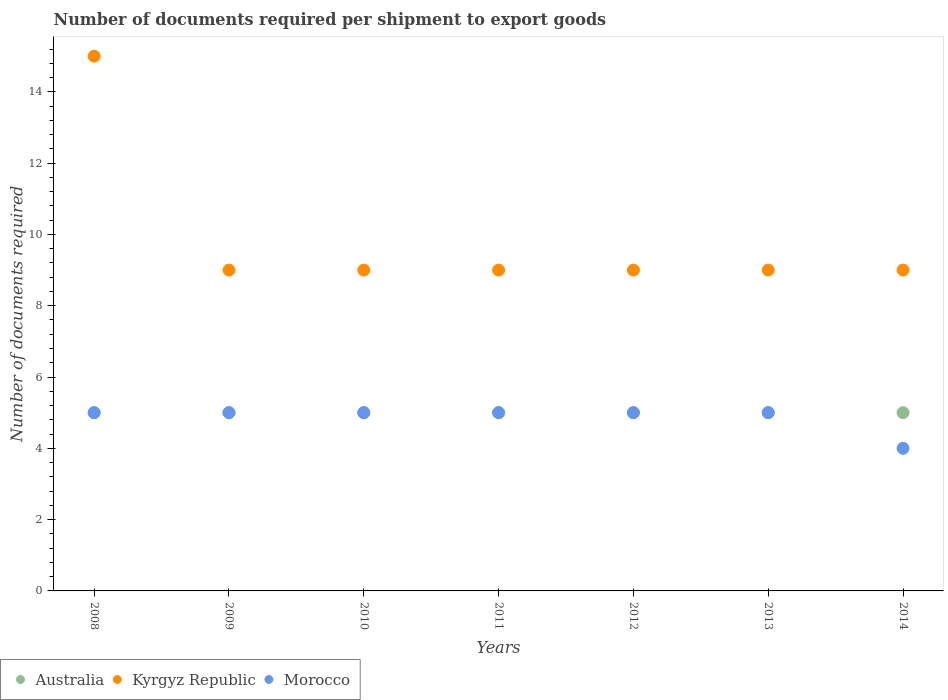Is the number of dotlines equal to the number of legend labels?
Make the answer very short. Yes. What is the number of documents required per shipment to export goods in Morocco in 2009?
Your answer should be very brief. 5. Across all years, what is the maximum number of documents required per shipment to export goods in Morocco?
Offer a terse response. 5. Across all years, what is the minimum number of documents required per shipment to export goods in Morocco?
Offer a very short reply. 4. In which year was the number of documents required per shipment to export goods in Morocco maximum?
Your answer should be very brief. 2008. In which year was the number of documents required per shipment to export goods in Morocco minimum?
Your answer should be very brief. 2014. What is the total number of documents required per shipment to export goods in Kyrgyz Republic in the graph?
Your answer should be very brief. 69. What is the difference between the number of documents required per shipment to export goods in Australia in 2009 and that in 2012?
Make the answer very short. 0. What is the difference between the number of documents required per shipment to export goods in Kyrgyz Republic in 2014 and the number of documents required per shipment to export goods in Australia in 2012?
Provide a short and direct response. 4. What is the average number of documents required per shipment to export goods in Kyrgyz Republic per year?
Make the answer very short. 9.86. In how many years, is the number of documents required per shipment to export goods in Australia greater than 11.2?
Offer a very short reply. 0. What is the ratio of the number of documents required per shipment to export goods in Morocco in 2010 to that in 2011?
Ensure brevity in your answer.  1. What is the difference between the highest and the lowest number of documents required per shipment to export goods in Australia?
Ensure brevity in your answer.  0. Is the sum of the number of documents required per shipment to export goods in Kyrgyz Republic in 2008 and 2011 greater than the maximum number of documents required per shipment to export goods in Morocco across all years?
Ensure brevity in your answer.  Yes. Is it the case that in every year, the sum of the number of documents required per shipment to export goods in Australia and number of documents required per shipment to export goods in Morocco  is greater than the number of documents required per shipment to export goods in Kyrgyz Republic?
Ensure brevity in your answer.  No. Does the number of documents required per shipment to export goods in Morocco monotonically increase over the years?
Ensure brevity in your answer.  No. How many dotlines are there?
Provide a short and direct response. 3. How many years are there in the graph?
Give a very brief answer. 7. What is the difference between two consecutive major ticks on the Y-axis?
Your response must be concise. 2. Are the values on the major ticks of Y-axis written in scientific E-notation?
Provide a short and direct response. No. Does the graph contain any zero values?
Give a very brief answer. No. What is the title of the graph?
Keep it short and to the point. Number of documents required per shipment to export goods. What is the label or title of the Y-axis?
Make the answer very short. Number of documents required. What is the Number of documents required in Australia in 2008?
Keep it short and to the point. 5. What is the Number of documents required in Morocco in 2008?
Keep it short and to the point. 5. What is the Number of documents required in Kyrgyz Republic in 2009?
Your answer should be compact. 9. What is the Number of documents required of Morocco in 2009?
Ensure brevity in your answer.  5. What is the Number of documents required in Australia in 2010?
Offer a very short reply. 5. What is the Number of documents required of Kyrgyz Republic in 2010?
Your response must be concise. 9. What is the Number of documents required in Australia in 2011?
Make the answer very short. 5. What is the Number of documents required in Kyrgyz Republic in 2012?
Give a very brief answer. 9. What is the Number of documents required of Morocco in 2012?
Make the answer very short. 5. What is the Number of documents required in Australia in 2013?
Provide a short and direct response. 5. What is the Number of documents required of Kyrgyz Republic in 2013?
Provide a succinct answer. 9. What is the Number of documents required in Kyrgyz Republic in 2014?
Your answer should be very brief. 9. Across all years, what is the maximum Number of documents required in Australia?
Provide a short and direct response. 5. Across all years, what is the maximum Number of documents required in Kyrgyz Republic?
Ensure brevity in your answer.  15. Across all years, what is the maximum Number of documents required of Morocco?
Offer a terse response. 5. Across all years, what is the minimum Number of documents required in Australia?
Make the answer very short. 5. What is the total Number of documents required of Australia in the graph?
Keep it short and to the point. 35. What is the total Number of documents required of Kyrgyz Republic in the graph?
Ensure brevity in your answer.  69. What is the difference between the Number of documents required of Kyrgyz Republic in 2008 and that in 2009?
Provide a short and direct response. 6. What is the difference between the Number of documents required of Morocco in 2008 and that in 2010?
Offer a terse response. 0. What is the difference between the Number of documents required in Australia in 2008 and that in 2011?
Your answer should be compact. 0. What is the difference between the Number of documents required in Morocco in 2008 and that in 2012?
Your response must be concise. 0. What is the difference between the Number of documents required in Australia in 2008 and that in 2013?
Your response must be concise. 0. What is the difference between the Number of documents required in Kyrgyz Republic in 2008 and that in 2013?
Your answer should be very brief. 6. What is the difference between the Number of documents required of Australia in 2008 and that in 2014?
Offer a terse response. 0. What is the difference between the Number of documents required in Australia in 2009 and that in 2011?
Ensure brevity in your answer.  0. What is the difference between the Number of documents required in Kyrgyz Republic in 2009 and that in 2011?
Keep it short and to the point. 0. What is the difference between the Number of documents required in Australia in 2009 and that in 2012?
Your answer should be compact. 0. What is the difference between the Number of documents required in Kyrgyz Republic in 2009 and that in 2012?
Keep it short and to the point. 0. What is the difference between the Number of documents required in Morocco in 2009 and that in 2012?
Give a very brief answer. 0. What is the difference between the Number of documents required of Australia in 2009 and that in 2013?
Offer a terse response. 0. What is the difference between the Number of documents required of Kyrgyz Republic in 2009 and that in 2013?
Give a very brief answer. 0. What is the difference between the Number of documents required in Australia in 2009 and that in 2014?
Give a very brief answer. 0. What is the difference between the Number of documents required of Morocco in 2010 and that in 2011?
Offer a very short reply. 0. What is the difference between the Number of documents required in Australia in 2010 and that in 2012?
Offer a very short reply. 0. What is the difference between the Number of documents required of Australia in 2010 and that in 2013?
Your response must be concise. 0. What is the difference between the Number of documents required in Kyrgyz Republic in 2010 and that in 2013?
Keep it short and to the point. 0. What is the difference between the Number of documents required in Morocco in 2010 and that in 2013?
Keep it short and to the point. 0. What is the difference between the Number of documents required of Australia in 2010 and that in 2014?
Keep it short and to the point. 0. What is the difference between the Number of documents required of Morocco in 2010 and that in 2014?
Offer a terse response. 1. What is the difference between the Number of documents required in Australia in 2011 and that in 2012?
Offer a very short reply. 0. What is the difference between the Number of documents required of Australia in 2012 and that in 2013?
Your response must be concise. 0. What is the difference between the Number of documents required of Kyrgyz Republic in 2012 and that in 2013?
Keep it short and to the point. 0. What is the difference between the Number of documents required of Kyrgyz Republic in 2012 and that in 2014?
Ensure brevity in your answer.  0. What is the difference between the Number of documents required in Morocco in 2012 and that in 2014?
Keep it short and to the point. 1. What is the difference between the Number of documents required of Australia in 2013 and that in 2014?
Give a very brief answer. 0. What is the difference between the Number of documents required in Kyrgyz Republic in 2013 and that in 2014?
Provide a short and direct response. 0. What is the difference between the Number of documents required of Morocco in 2013 and that in 2014?
Keep it short and to the point. 1. What is the difference between the Number of documents required of Australia in 2008 and the Number of documents required of Morocco in 2009?
Offer a very short reply. 0. What is the difference between the Number of documents required in Australia in 2008 and the Number of documents required in Morocco in 2010?
Provide a succinct answer. 0. What is the difference between the Number of documents required in Australia in 2008 and the Number of documents required in Kyrgyz Republic in 2011?
Ensure brevity in your answer.  -4. What is the difference between the Number of documents required in Australia in 2008 and the Number of documents required in Morocco in 2011?
Your response must be concise. 0. What is the difference between the Number of documents required in Kyrgyz Republic in 2008 and the Number of documents required in Morocco in 2011?
Give a very brief answer. 10. What is the difference between the Number of documents required of Australia in 2008 and the Number of documents required of Morocco in 2012?
Keep it short and to the point. 0. What is the difference between the Number of documents required in Kyrgyz Republic in 2008 and the Number of documents required in Morocco in 2013?
Offer a very short reply. 10. What is the difference between the Number of documents required in Australia in 2008 and the Number of documents required in Kyrgyz Republic in 2014?
Ensure brevity in your answer.  -4. What is the difference between the Number of documents required of Australia in 2008 and the Number of documents required of Morocco in 2014?
Give a very brief answer. 1. What is the difference between the Number of documents required of Australia in 2009 and the Number of documents required of Kyrgyz Republic in 2011?
Keep it short and to the point. -4. What is the difference between the Number of documents required in Kyrgyz Republic in 2009 and the Number of documents required in Morocco in 2011?
Keep it short and to the point. 4. What is the difference between the Number of documents required in Australia in 2009 and the Number of documents required in Kyrgyz Republic in 2012?
Ensure brevity in your answer.  -4. What is the difference between the Number of documents required of Australia in 2009 and the Number of documents required of Morocco in 2012?
Your response must be concise. 0. What is the difference between the Number of documents required in Kyrgyz Republic in 2009 and the Number of documents required in Morocco in 2012?
Ensure brevity in your answer.  4. What is the difference between the Number of documents required in Kyrgyz Republic in 2009 and the Number of documents required in Morocco in 2013?
Ensure brevity in your answer.  4. What is the difference between the Number of documents required of Australia in 2009 and the Number of documents required of Morocco in 2014?
Provide a short and direct response. 1. What is the difference between the Number of documents required of Australia in 2010 and the Number of documents required of Kyrgyz Republic in 2011?
Your answer should be very brief. -4. What is the difference between the Number of documents required of Australia in 2010 and the Number of documents required of Morocco in 2011?
Provide a succinct answer. 0. What is the difference between the Number of documents required of Kyrgyz Republic in 2010 and the Number of documents required of Morocco in 2011?
Provide a succinct answer. 4. What is the difference between the Number of documents required of Australia in 2010 and the Number of documents required of Morocco in 2012?
Your response must be concise. 0. What is the difference between the Number of documents required in Australia in 2010 and the Number of documents required in Morocco in 2013?
Offer a terse response. 0. What is the difference between the Number of documents required in Australia in 2010 and the Number of documents required in Kyrgyz Republic in 2014?
Your answer should be compact. -4. What is the difference between the Number of documents required of Australia in 2010 and the Number of documents required of Morocco in 2014?
Make the answer very short. 1. What is the difference between the Number of documents required in Australia in 2011 and the Number of documents required in Kyrgyz Republic in 2012?
Ensure brevity in your answer.  -4. What is the difference between the Number of documents required in Australia in 2011 and the Number of documents required in Kyrgyz Republic in 2013?
Make the answer very short. -4. What is the difference between the Number of documents required of Kyrgyz Republic in 2011 and the Number of documents required of Morocco in 2013?
Make the answer very short. 4. What is the difference between the Number of documents required in Australia in 2011 and the Number of documents required in Kyrgyz Republic in 2014?
Ensure brevity in your answer.  -4. What is the difference between the Number of documents required in Australia in 2011 and the Number of documents required in Morocco in 2014?
Provide a succinct answer. 1. What is the difference between the Number of documents required in Australia in 2012 and the Number of documents required in Kyrgyz Republic in 2013?
Offer a very short reply. -4. What is the difference between the Number of documents required of Australia in 2012 and the Number of documents required of Morocco in 2013?
Provide a succinct answer. 0. What is the difference between the Number of documents required of Kyrgyz Republic in 2013 and the Number of documents required of Morocco in 2014?
Make the answer very short. 5. What is the average Number of documents required of Kyrgyz Republic per year?
Your answer should be very brief. 9.86. What is the average Number of documents required in Morocco per year?
Make the answer very short. 4.86. In the year 2008, what is the difference between the Number of documents required of Australia and Number of documents required of Kyrgyz Republic?
Offer a very short reply. -10. In the year 2008, what is the difference between the Number of documents required of Australia and Number of documents required of Morocco?
Give a very brief answer. 0. In the year 2008, what is the difference between the Number of documents required of Kyrgyz Republic and Number of documents required of Morocco?
Keep it short and to the point. 10. In the year 2009, what is the difference between the Number of documents required in Australia and Number of documents required in Kyrgyz Republic?
Ensure brevity in your answer.  -4. In the year 2009, what is the difference between the Number of documents required in Australia and Number of documents required in Morocco?
Your answer should be very brief. 0. In the year 2009, what is the difference between the Number of documents required in Kyrgyz Republic and Number of documents required in Morocco?
Make the answer very short. 4. In the year 2011, what is the difference between the Number of documents required in Australia and Number of documents required in Morocco?
Your answer should be very brief. 0. In the year 2011, what is the difference between the Number of documents required in Kyrgyz Republic and Number of documents required in Morocco?
Make the answer very short. 4. In the year 2013, what is the difference between the Number of documents required in Australia and Number of documents required in Morocco?
Provide a succinct answer. 0. In the year 2014, what is the difference between the Number of documents required of Australia and Number of documents required of Kyrgyz Republic?
Offer a very short reply. -4. What is the ratio of the Number of documents required in Australia in 2008 to that in 2009?
Your answer should be very brief. 1. What is the ratio of the Number of documents required in Morocco in 2008 to that in 2010?
Your response must be concise. 1. What is the ratio of the Number of documents required of Kyrgyz Republic in 2008 to that in 2011?
Provide a succinct answer. 1.67. What is the ratio of the Number of documents required of Australia in 2008 to that in 2012?
Give a very brief answer. 1. What is the ratio of the Number of documents required of Morocco in 2008 to that in 2012?
Your answer should be compact. 1. What is the ratio of the Number of documents required in Kyrgyz Republic in 2008 to that in 2013?
Your answer should be very brief. 1.67. What is the ratio of the Number of documents required in Morocco in 2008 to that in 2013?
Provide a succinct answer. 1. What is the ratio of the Number of documents required of Australia in 2008 to that in 2014?
Ensure brevity in your answer.  1. What is the ratio of the Number of documents required in Kyrgyz Republic in 2008 to that in 2014?
Keep it short and to the point. 1.67. What is the ratio of the Number of documents required of Morocco in 2008 to that in 2014?
Offer a very short reply. 1.25. What is the ratio of the Number of documents required of Kyrgyz Republic in 2009 to that in 2010?
Your answer should be very brief. 1. What is the ratio of the Number of documents required of Australia in 2009 to that in 2011?
Ensure brevity in your answer.  1. What is the ratio of the Number of documents required in Kyrgyz Republic in 2009 to that in 2011?
Your answer should be compact. 1. What is the ratio of the Number of documents required in Australia in 2009 to that in 2012?
Provide a succinct answer. 1. What is the ratio of the Number of documents required in Kyrgyz Republic in 2009 to that in 2012?
Ensure brevity in your answer.  1. What is the ratio of the Number of documents required in Kyrgyz Republic in 2009 to that in 2013?
Ensure brevity in your answer.  1. What is the ratio of the Number of documents required in Australia in 2009 to that in 2014?
Offer a very short reply. 1. What is the ratio of the Number of documents required of Australia in 2010 to that in 2011?
Your answer should be compact. 1. What is the ratio of the Number of documents required in Kyrgyz Republic in 2010 to that in 2011?
Keep it short and to the point. 1. What is the ratio of the Number of documents required in Morocco in 2010 to that in 2011?
Ensure brevity in your answer.  1. What is the ratio of the Number of documents required of Australia in 2010 to that in 2012?
Make the answer very short. 1. What is the ratio of the Number of documents required of Kyrgyz Republic in 2010 to that in 2012?
Provide a short and direct response. 1. What is the ratio of the Number of documents required in Morocco in 2010 to that in 2012?
Your answer should be very brief. 1. What is the ratio of the Number of documents required in Kyrgyz Republic in 2010 to that in 2013?
Make the answer very short. 1. What is the ratio of the Number of documents required in Australia in 2010 to that in 2014?
Offer a very short reply. 1. What is the ratio of the Number of documents required in Kyrgyz Republic in 2010 to that in 2014?
Make the answer very short. 1. What is the ratio of the Number of documents required of Kyrgyz Republic in 2011 to that in 2013?
Ensure brevity in your answer.  1. What is the ratio of the Number of documents required of Morocco in 2011 to that in 2013?
Your answer should be compact. 1. What is the ratio of the Number of documents required of Australia in 2012 to that in 2013?
Keep it short and to the point. 1. What is the ratio of the Number of documents required of Morocco in 2012 to that in 2013?
Give a very brief answer. 1. What is the ratio of the Number of documents required of Australia in 2012 to that in 2014?
Provide a succinct answer. 1. What is the ratio of the Number of documents required in Morocco in 2012 to that in 2014?
Your response must be concise. 1.25. What is the ratio of the Number of documents required in Australia in 2013 to that in 2014?
Give a very brief answer. 1. What is the ratio of the Number of documents required of Kyrgyz Republic in 2013 to that in 2014?
Your answer should be compact. 1. What is the ratio of the Number of documents required in Morocco in 2013 to that in 2014?
Provide a succinct answer. 1.25. What is the difference between the highest and the second highest Number of documents required of Australia?
Keep it short and to the point. 0. What is the difference between the highest and the second highest Number of documents required of Kyrgyz Republic?
Your answer should be very brief. 6. 